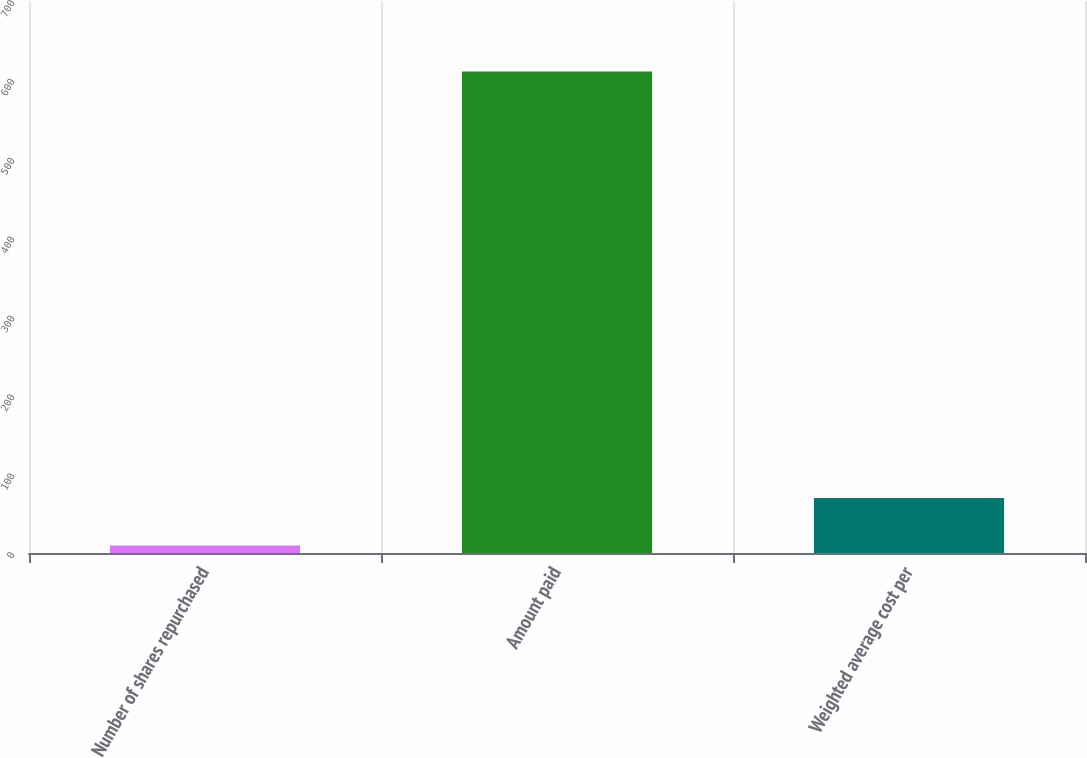<chart> <loc_0><loc_0><loc_500><loc_500><bar_chart><fcel>Number of shares repurchased<fcel>Amount paid<fcel>Weighted average cost per<nl><fcel>9.6<fcel>610.7<fcel>69.71<nl></chart> 